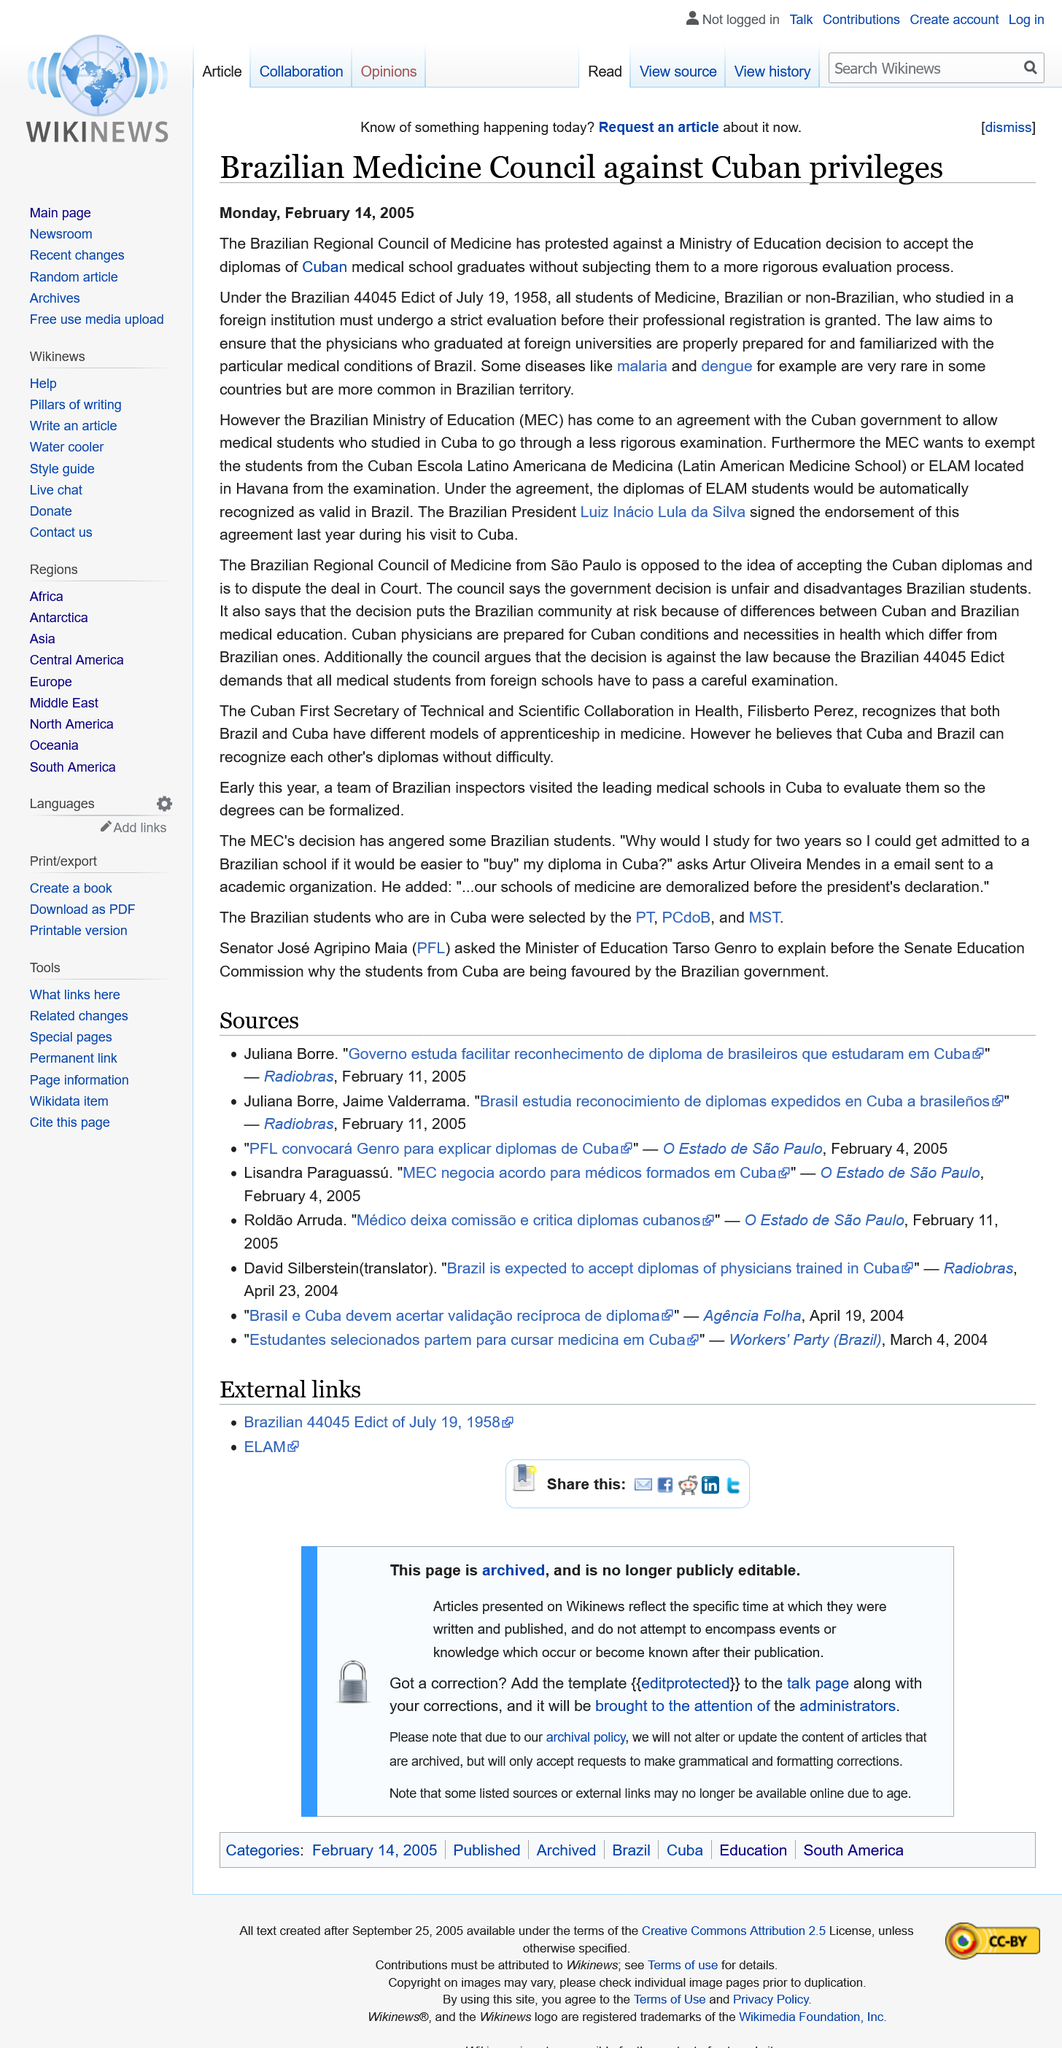Indicate a few pertinent items in this graphic. The Brazilian Regional Council of Medicine was protesting the decision of the Ministry of Education, which had been made. The Medical Council specifically targeted Cuban nationals in their protest. The article was published on February 14, 2005, in the format DD/MM/YYYY. 